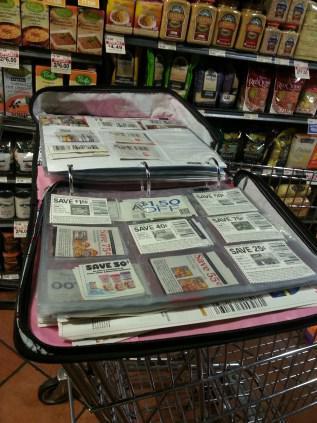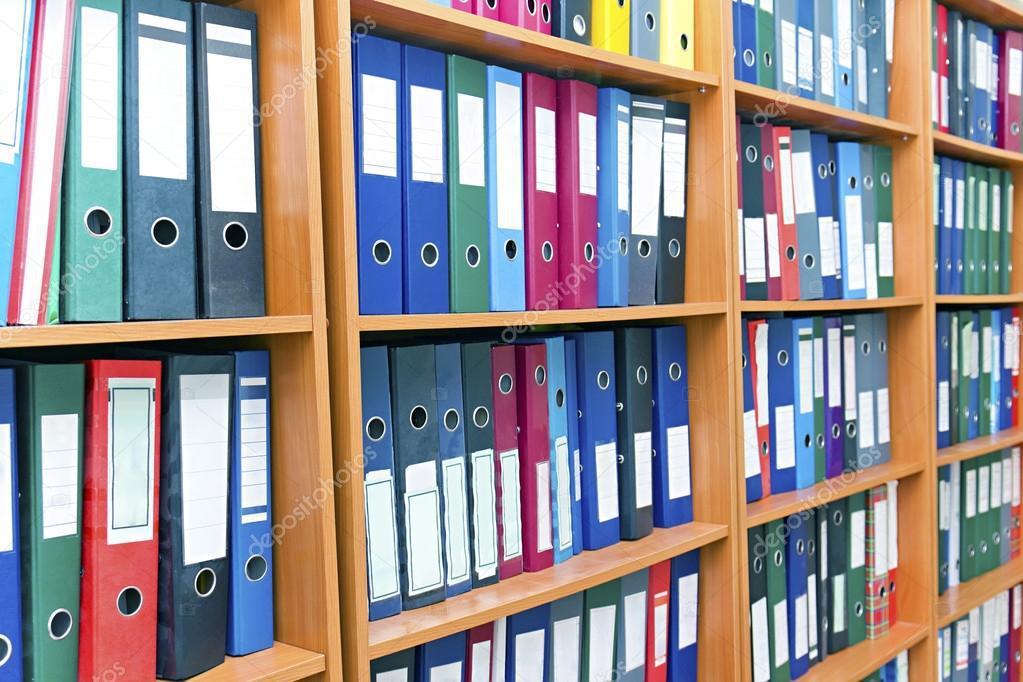The first image is the image on the left, the second image is the image on the right. Assess this claim about the two images: "One image shows a wall of shelves containing vertical binders, and the other image includes at least one open binder filled with plastic-sheeted items.". Correct or not? Answer yes or no. Yes. The first image is the image on the left, the second image is the image on the right. Evaluate the accuracy of this statement regarding the images: "There are rows of colorful binders and an open binder.". Is it true? Answer yes or no. Yes. 